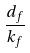<formula> <loc_0><loc_0><loc_500><loc_500>\frac { d _ { f } } { k _ { f } }</formula> 